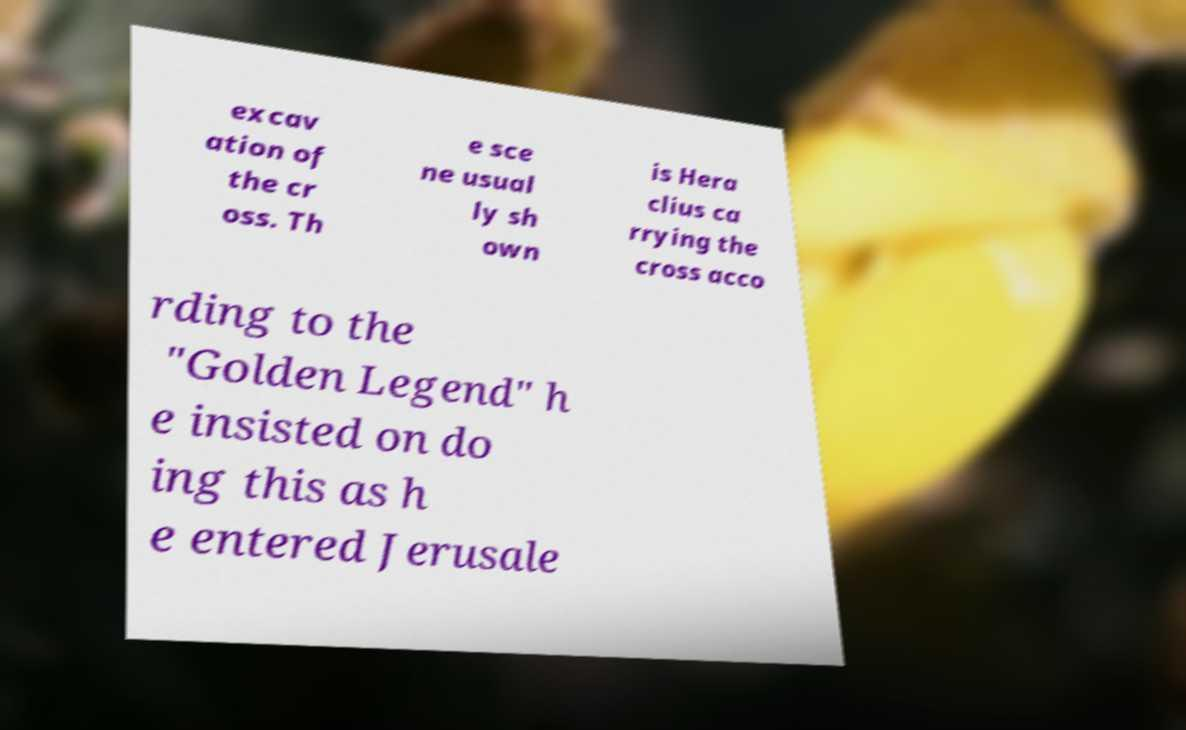Can you accurately transcribe the text from the provided image for me? excav ation of the cr oss. Th e sce ne usual ly sh own is Hera clius ca rrying the cross acco rding to the "Golden Legend" h e insisted on do ing this as h e entered Jerusale 